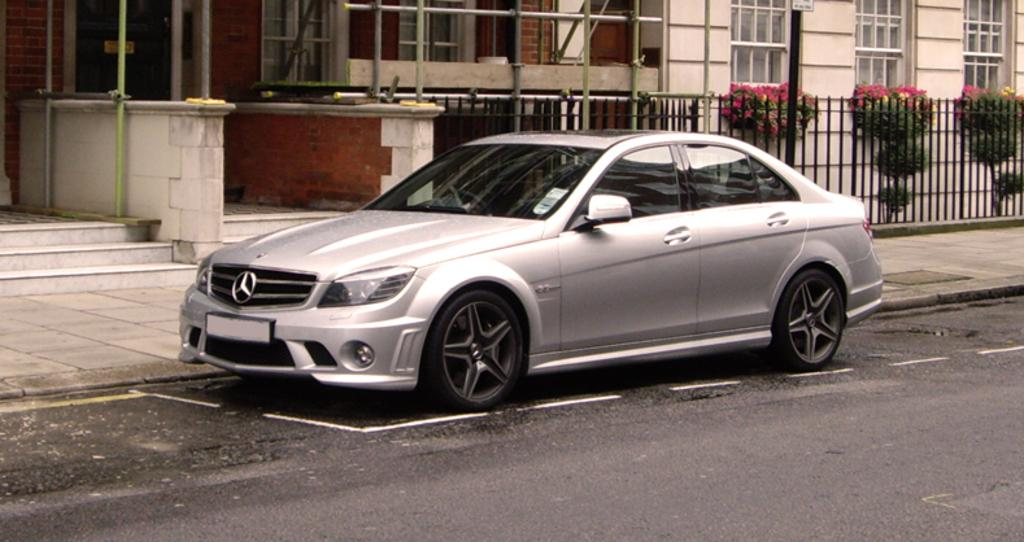What is parked on the road in the image? There is a car parked on the road in the image. What can be seen in the background of the image? There are buildings with windows, a group of metal poles, a fence, plants, and a staircase in the background. What type of suit is the car wearing in the image? Cars do not wear suits; the question is not applicable to the image. 